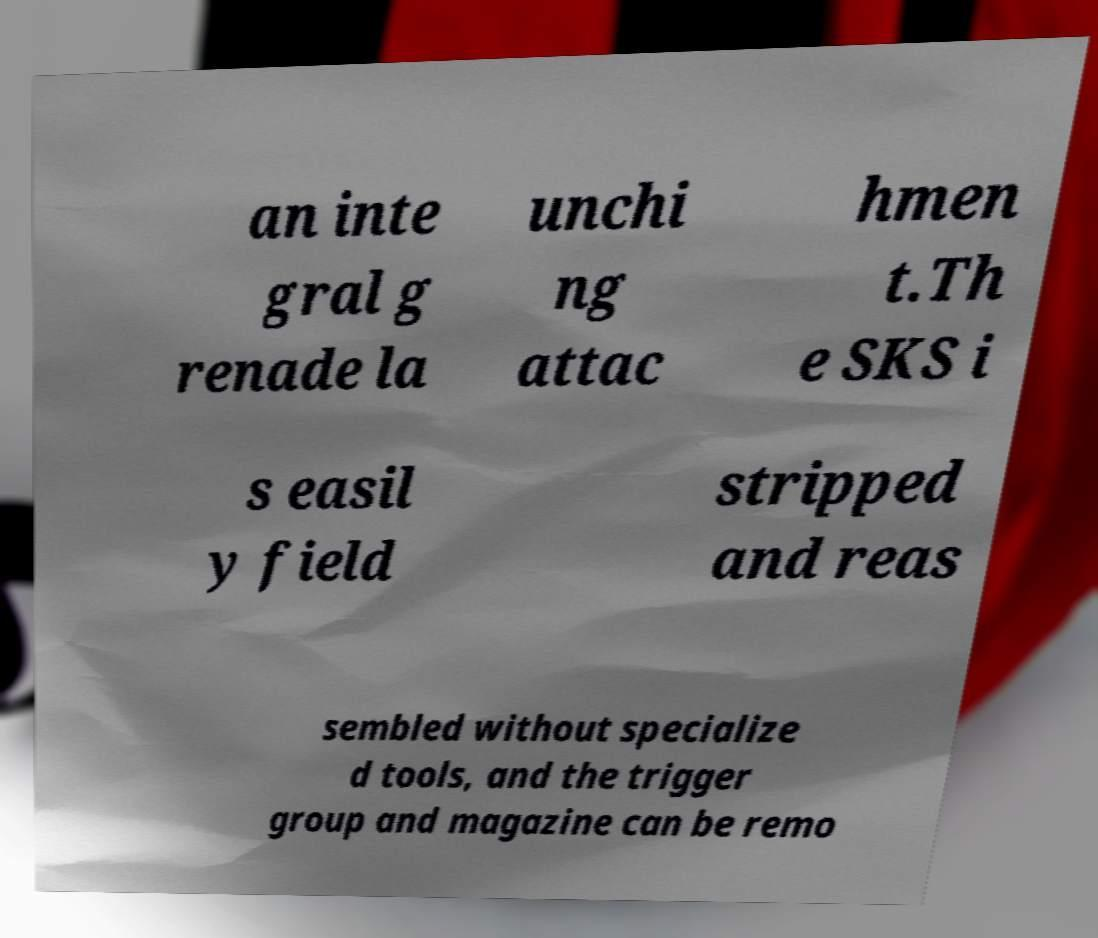I need the written content from this picture converted into text. Can you do that? an inte gral g renade la unchi ng attac hmen t.Th e SKS i s easil y field stripped and reas sembled without specialize d tools, and the trigger group and magazine can be remo 